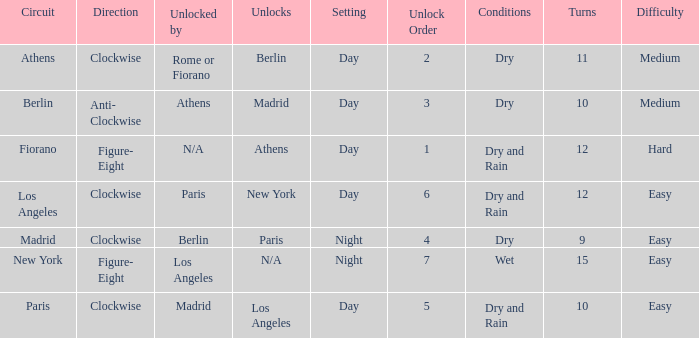What is the lowest unlock order for the athens circuit? 2.0. 